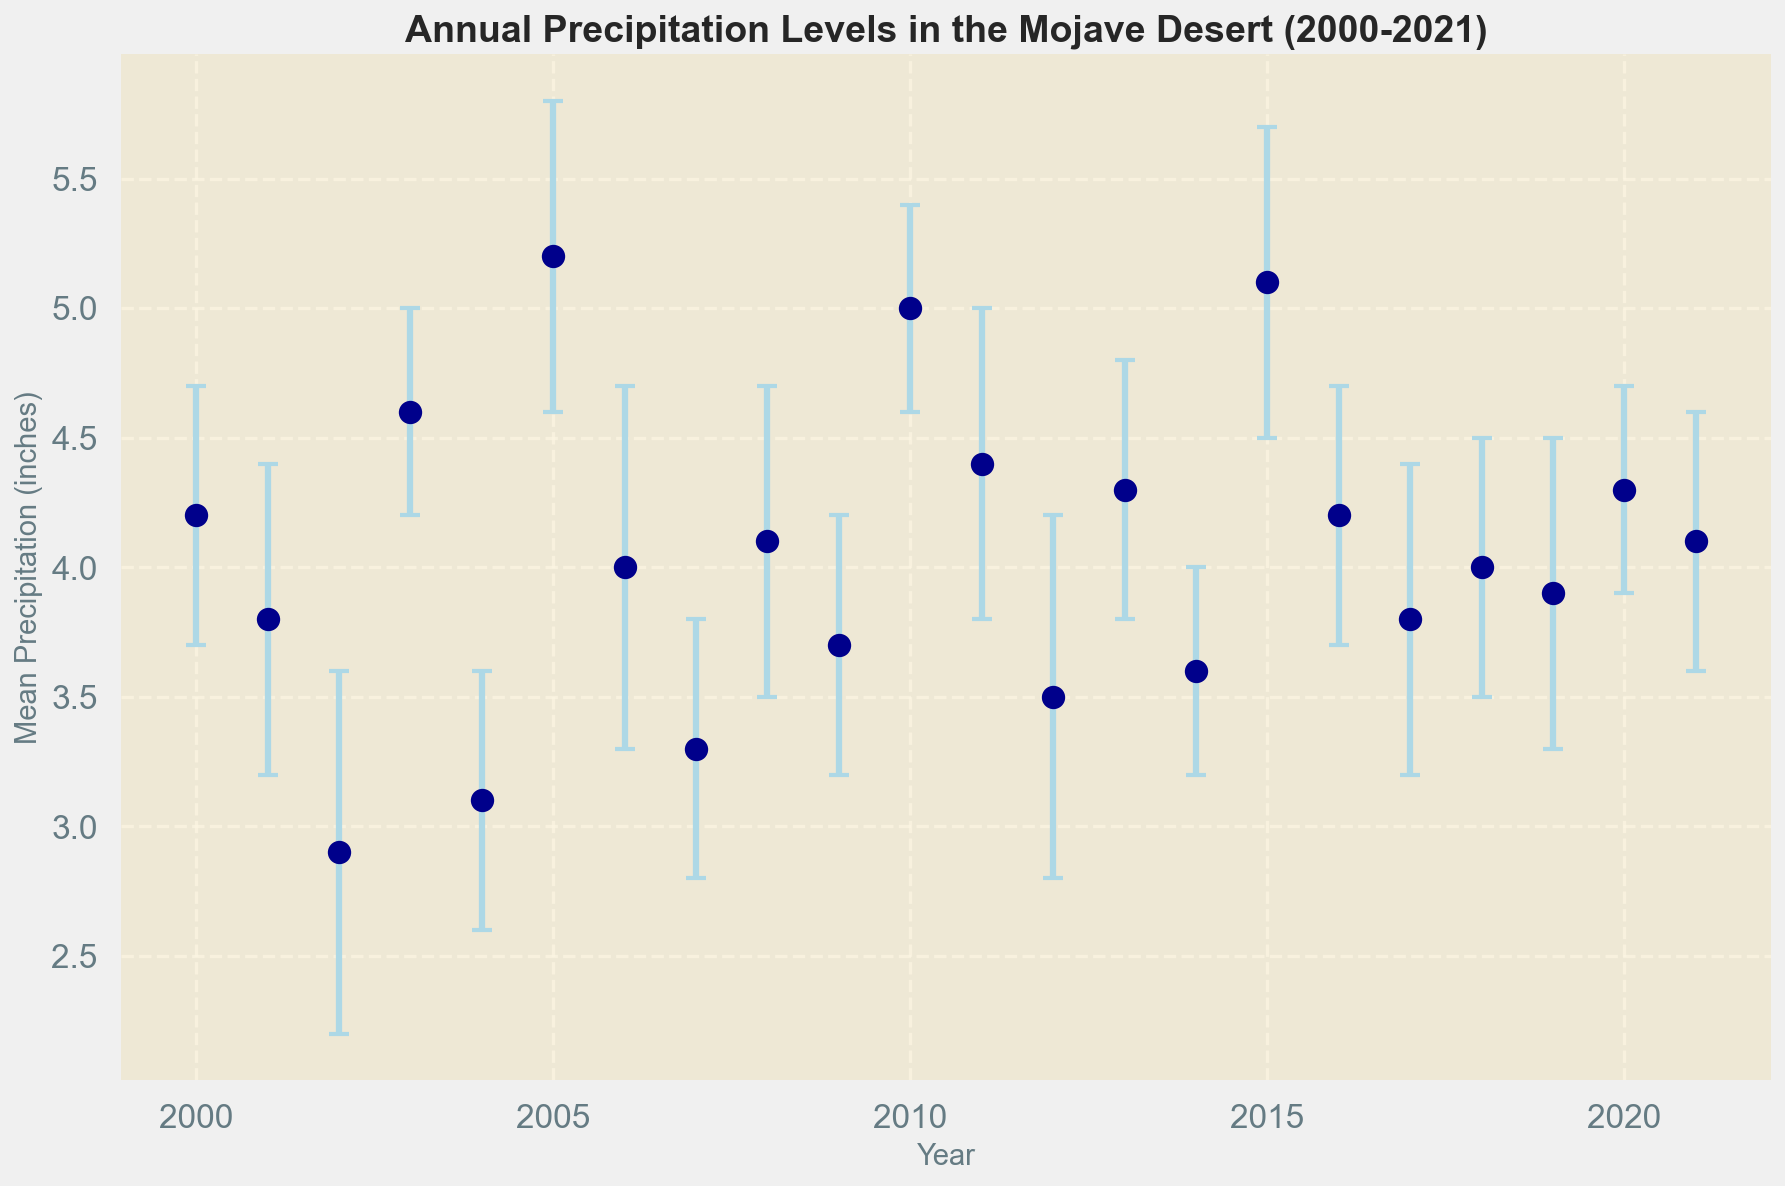What is the mean precipitation level in 2010? To find the mean precipitation level in 2010, locate the data point at the year 2010 and read the corresponding value on the y-axis. The figure shows mean precipitation is 5.0 inches in 2010.
Answer: 5.0 inches Which year had the lowest mean precipitation level? Identify the year with the lowest data point on the plot for mean precipitation. The year 2002 had the lowest mean precipitation level of 2.9 inches.
Answer: 2002 What is the range of mean precipitation levels from 2000 to 2021? The range is calculated as the difference between the maximum and minimum mean precipitation levels. From the data, the maximum mean is 5.2 inches (2005), and the minimum mean is 2.9 inches (2002). The range is 5.2 - 2.9 = 2.3 inches.
Answer: 2.3 inches In which year was the mean precipitation level the closest to 4.0 inches? Locate the data points around the 4.0 inches mark and find the closest value. The values in 2000, 2008, 2016, and 2018 were 4.2, 4.1, 4.2, and 4.0 inches respectively; the closest (exact match) is 2018.
Answer: 2018 How does the mean precipitation level in 2005 compare to the mean level in 2015? Compare the heights of the points at 2005 and 2015. In 2005, the mean precipitation is 5.2 inches, and in 2015, it is 5.1 inches. So, 2005 is slightly higher.
Answer: 2005 (slightly higher) What is the average mean precipitation for the years 2000, 2010, and 2020? Average the mean precipitation levels for these years. (4.2 [2000] + 5.0 [2010] + 4.3 [2020]) / 3 = 4.5
Answer: 4.5 inches Which year has the largest standard deviation in precipitation? Identify the year with the largest error bar (standard deviation). The year 2002 had the largest standard deviation of 0.7 inches.
Answer: 2002 Has the mean precipitation in 2021 returned to the levels seen in 2000? Compare the values for 2021 and 2000. The figure shows the mean precipitation for both years is 4.1 and 4.2 inches respectively. They are similar, but not identical.
Answer: No, but they are similar What is the difference in mean precipitation between 2002 and 2003? Subtract the mean precipitation for 2002 from that of 2003. The values are 4.6 (2003) - 2.9 (2002) = 1.7 inches.
Answer: 1.7 inches Which year had a mean precipitation level not significantly different from 4.1 inches, considering the error bars? Find the years where the mean value is within the error bars that overlap with 4.1 inches. Years 2008, 2018, and 2021 all fit this condition.
Answer: 2008, 2018, 2021 